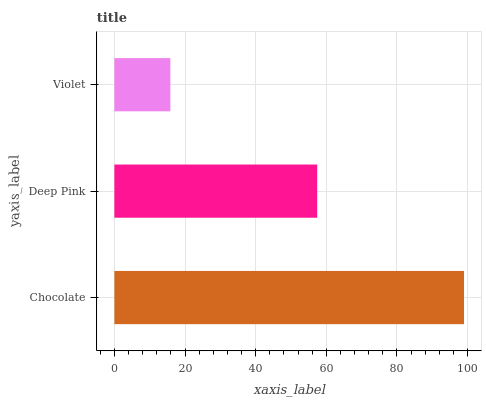Is Violet the minimum?
Answer yes or no. Yes. Is Chocolate the maximum?
Answer yes or no. Yes. Is Deep Pink the minimum?
Answer yes or no. No. Is Deep Pink the maximum?
Answer yes or no. No. Is Chocolate greater than Deep Pink?
Answer yes or no. Yes. Is Deep Pink less than Chocolate?
Answer yes or no. Yes. Is Deep Pink greater than Chocolate?
Answer yes or no. No. Is Chocolate less than Deep Pink?
Answer yes or no. No. Is Deep Pink the high median?
Answer yes or no. Yes. Is Deep Pink the low median?
Answer yes or no. Yes. Is Violet the high median?
Answer yes or no. No. Is Chocolate the low median?
Answer yes or no. No. 